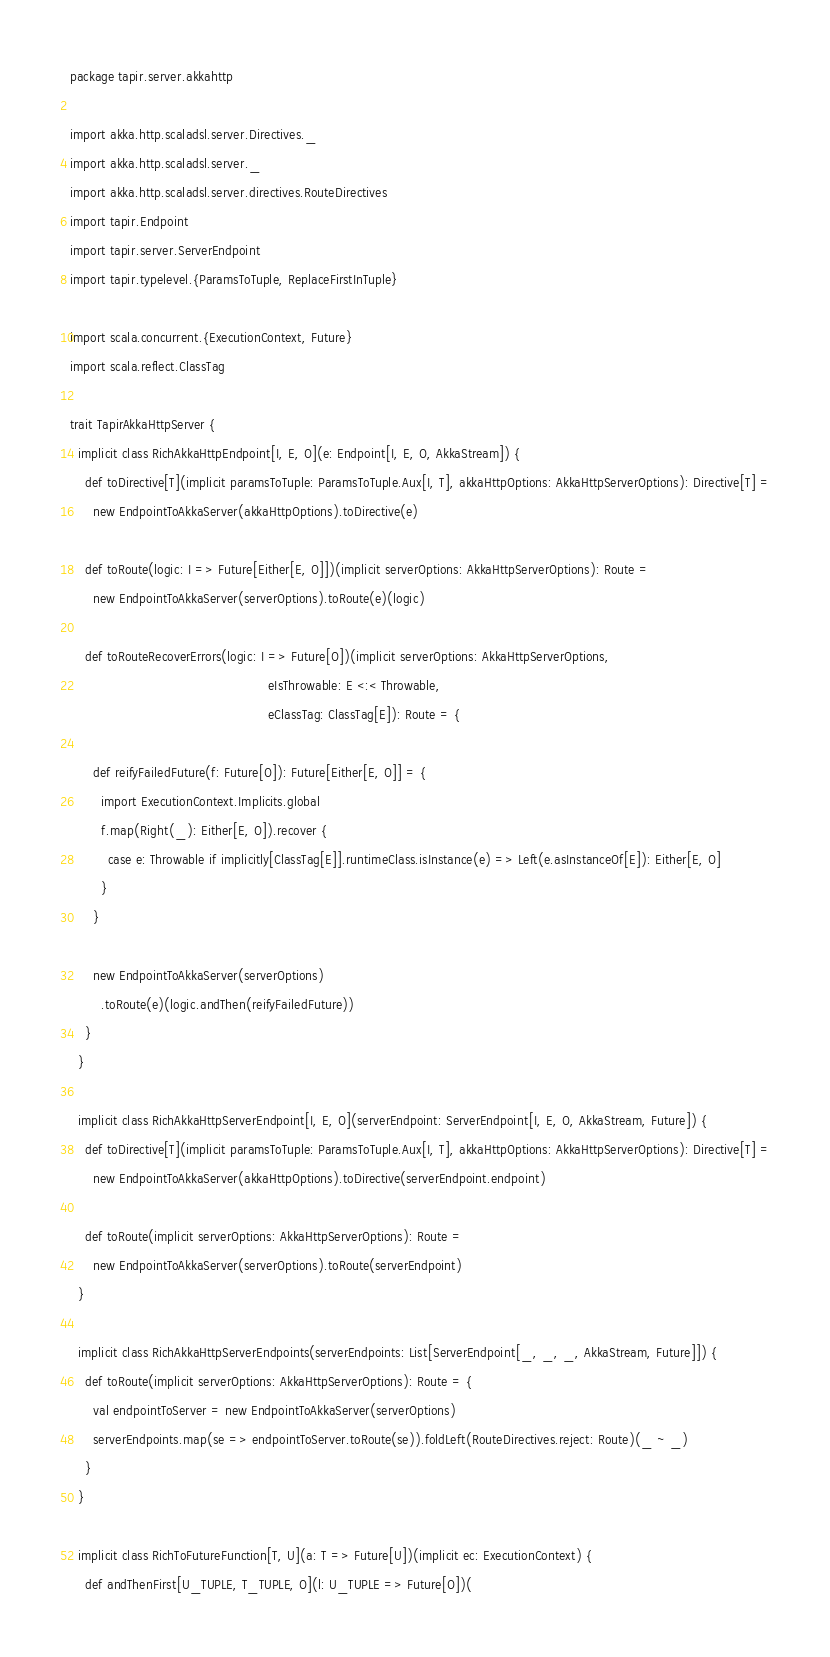<code> <loc_0><loc_0><loc_500><loc_500><_Scala_>package tapir.server.akkahttp

import akka.http.scaladsl.server.Directives._
import akka.http.scaladsl.server._
import akka.http.scaladsl.server.directives.RouteDirectives
import tapir.Endpoint
import tapir.server.ServerEndpoint
import tapir.typelevel.{ParamsToTuple, ReplaceFirstInTuple}

import scala.concurrent.{ExecutionContext, Future}
import scala.reflect.ClassTag

trait TapirAkkaHttpServer {
  implicit class RichAkkaHttpEndpoint[I, E, O](e: Endpoint[I, E, O, AkkaStream]) {
    def toDirective[T](implicit paramsToTuple: ParamsToTuple.Aux[I, T], akkaHttpOptions: AkkaHttpServerOptions): Directive[T] =
      new EndpointToAkkaServer(akkaHttpOptions).toDirective(e)

    def toRoute(logic: I => Future[Either[E, O]])(implicit serverOptions: AkkaHttpServerOptions): Route =
      new EndpointToAkkaServer(serverOptions).toRoute(e)(logic)

    def toRouteRecoverErrors(logic: I => Future[O])(implicit serverOptions: AkkaHttpServerOptions,
                                                    eIsThrowable: E <:< Throwable,
                                                    eClassTag: ClassTag[E]): Route = {

      def reifyFailedFuture(f: Future[O]): Future[Either[E, O]] = {
        import ExecutionContext.Implicits.global
        f.map(Right(_): Either[E, O]).recover {
          case e: Throwable if implicitly[ClassTag[E]].runtimeClass.isInstance(e) => Left(e.asInstanceOf[E]): Either[E, O]
        }
      }

      new EndpointToAkkaServer(serverOptions)
        .toRoute(e)(logic.andThen(reifyFailedFuture))
    }
  }

  implicit class RichAkkaHttpServerEndpoint[I, E, O](serverEndpoint: ServerEndpoint[I, E, O, AkkaStream, Future]) {
    def toDirective[T](implicit paramsToTuple: ParamsToTuple.Aux[I, T], akkaHttpOptions: AkkaHttpServerOptions): Directive[T] =
      new EndpointToAkkaServer(akkaHttpOptions).toDirective(serverEndpoint.endpoint)

    def toRoute(implicit serverOptions: AkkaHttpServerOptions): Route =
      new EndpointToAkkaServer(serverOptions).toRoute(serverEndpoint)
  }

  implicit class RichAkkaHttpServerEndpoints(serverEndpoints: List[ServerEndpoint[_, _, _, AkkaStream, Future]]) {
    def toRoute(implicit serverOptions: AkkaHttpServerOptions): Route = {
      val endpointToServer = new EndpointToAkkaServer(serverOptions)
      serverEndpoints.map(se => endpointToServer.toRoute(se)).foldLeft(RouteDirectives.reject: Route)(_ ~ _)
    }
  }

  implicit class RichToFutureFunction[T, U](a: T => Future[U])(implicit ec: ExecutionContext) {
    def andThenFirst[U_TUPLE, T_TUPLE, O](l: U_TUPLE => Future[O])(</code> 